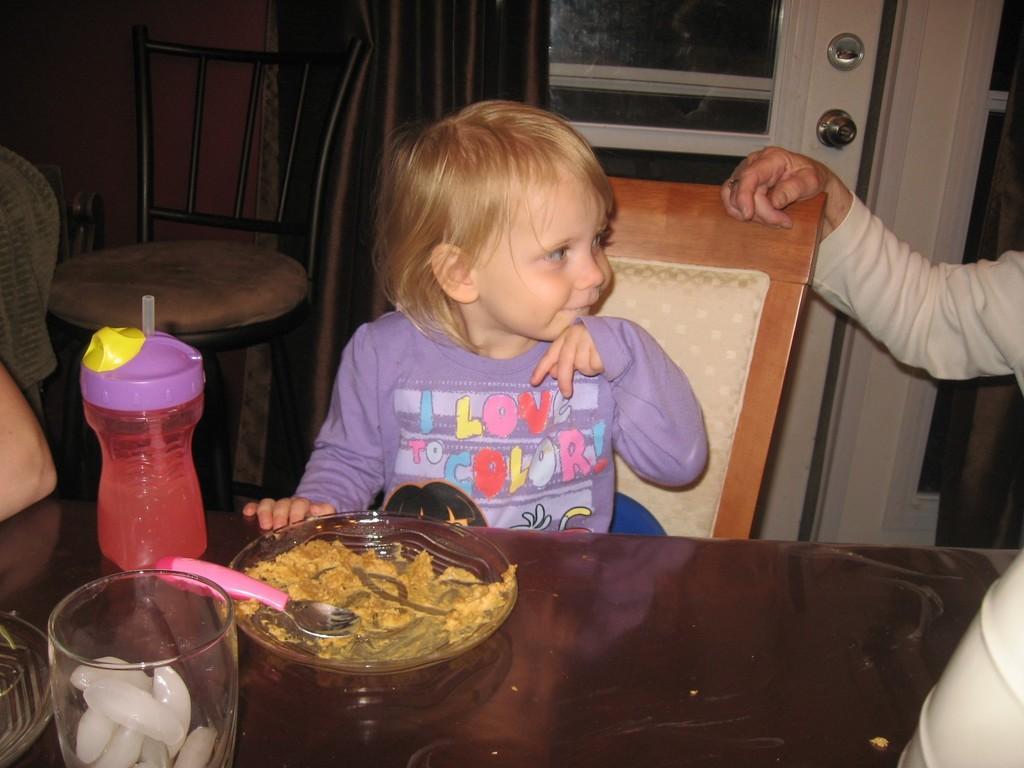In one or two sentences, can you explain what this image depicts? In this image, there are a few people. We can see a table with some objects like a plate with a spoon, a bottle and a glass. We can also see a white colored object on the bottom right corner. We can see a chair, a door and some curtains. We can also see the wall. 